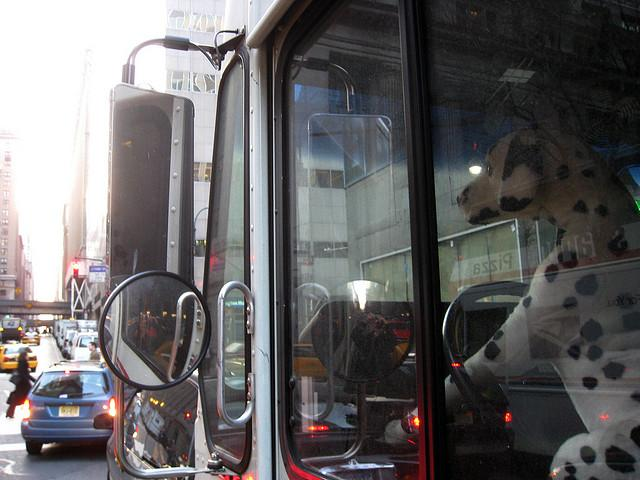Which lens is used in bus side mirror?

Choices:
A) convex
B) pin point
C) cortex
D) concave convex 